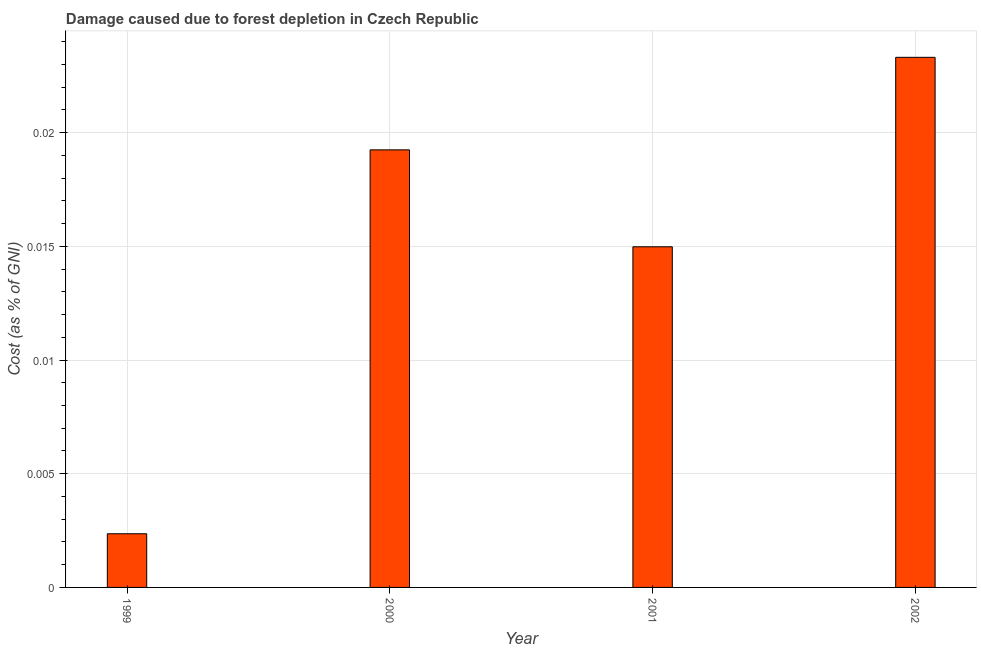Does the graph contain grids?
Your answer should be very brief. Yes. What is the title of the graph?
Your answer should be very brief. Damage caused due to forest depletion in Czech Republic. What is the label or title of the X-axis?
Your response must be concise. Year. What is the label or title of the Y-axis?
Give a very brief answer. Cost (as % of GNI). What is the damage caused due to forest depletion in 2001?
Your answer should be compact. 0.01. Across all years, what is the maximum damage caused due to forest depletion?
Provide a short and direct response. 0.02. Across all years, what is the minimum damage caused due to forest depletion?
Make the answer very short. 0. What is the sum of the damage caused due to forest depletion?
Offer a very short reply. 0.06. What is the difference between the damage caused due to forest depletion in 2000 and 2002?
Ensure brevity in your answer.  -0. What is the average damage caused due to forest depletion per year?
Provide a succinct answer. 0.01. What is the median damage caused due to forest depletion?
Provide a succinct answer. 0.02. Do a majority of the years between 1999 and 2001 (inclusive) have damage caused due to forest depletion greater than 0.018 %?
Provide a short and direct response. No. What is the ratio of the damage caused due to forest depletion in 1999 to that in 2001?
Your answer should be very brief. 0.16. Is the damage caused due to forest depletion in 2000 less than that in 2002?
Provide a short and direct response. Yes. What is the difference between the highest and the second highest damage caused due to forest depletion?
Your response must be concise. 0. Is the sum of the damage caused due to forest depletion in 2000 and 2001 greater than the maximum damage caused due to forest depletion across all years?
Your answer should be compact. Yes. What is the difference between the highest and the lowest damage caused due to forest depletion?
Provide a short and direct response. 0.02. How many bars are there?
Your response must be concise. 4. How many years are there in the graph?
Offer a very short reply. 4. What is the difference between two consecutive major ticks on the Y-axis?
Your answer should be very brief. 0.01. Are the values on the major ticks of Y-axis written in scientific E-notation?
Ensure brevity in your answer.  No. What is the Cost (as % of GNI) in 1999?
Your answer should be very brief. 0. What is the Cost (as % of GNI) in 2000?
Offer a terse response. 0.02. What is the Cost (as % of GNI) of 2001?
Give a very brief answer. 0.01. What is the Cost (as % of GNI) of 2002?
Give a very brief answer. 0.02. What is the difference between the Cost (as % of GNI) in 1999 and 2000?
Ensure brevity in your answer.  -0.02. What is the difference between the Cost (as % of GNI) in 1999 and 2001?
Provide a short and direct response. -0.01. What is the difference between the Cost (as % of GNI) in 1999 and 2002?
Your response must be concise. -0.02. What is the difference between the Cost (as % of GNI) in 2000 and 2001?
Your answer should be very brief. 0. What is the difference between the Cost (as % of GNI) in 2000 and 2002?
Provide a short and direct response. -0. What is the difference between the Cost (as % of GNI) in 2001 and 2002?
Provide a short and direct response. -0.01. What is the ratio of the Cost (as % of GNI) in 1999 to that in 2000?
Keep it short and to the point. 0.12. What is the ratio of the Cost (as % of GNI) in 1999 to that in 2001?
Offer a very short reply. 0.16. What is the ratio of the Cost (as % of GNI) in 1999 to that in 2002?
Provide a succinct answer. 0.1. What is the ratio of the Cost (as % of GNI) in 2000 to that in 2001?
Offer a terse response. 1.28. What is the ratio of the Cost (as % of GNI) in 2000 to that in 2002?
Make the answer very short. 0.82. What is the ratio of the Cost (as % of GNI) in 2001 to that in 2002?
Ensure brevity in your answer.  0.64. 